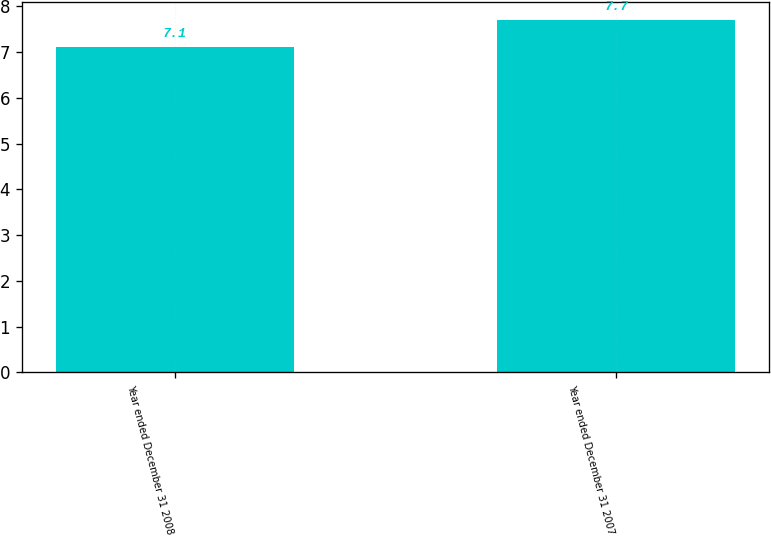Convert chart. <chart><loc_0><loc_0><loc_500><loc_500><bar_chart><fcel>Year ended December 31 2008<fcel>Year ended December 31 2007<nl><fcel>7.1<fcel>7.7<nl></chart> 